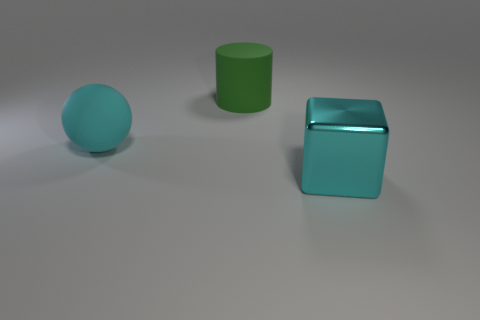The cyan object that is the same size as the cyan ball is what shape?
Your response must be concise. Cube. Is the color of the large block the same as the large matte thing that is on the right side of the rubber sphere?
Make the answer very short. No. What number of things are either things that are left of the large cyan cube or big objects in front of the large rubber cylinder?
Provide a short and direct response. 3. There is a sphere that is the same size as the green rubber cylinder; what material is it?
Your response must be concise. Rubber. How many other objects are there of the same material as the cylinder?
Ensure brevity in your answer.  1. There is a large cyan thing that is to the right of the large green rubber thing; is it the same shape as the large matte object that is on the right side of the rubber sphere?
Your answer should be very brief. No. There is a object that is behind the cyan object that is behind the big thing that is on the right side of the big cylinder; what color is it?
Provide a short and direct response. Green. What number of other objects are there of the same color as the large cube?
Keep it short and to the point. 1. Is the number of big cyan rubber spheres less than the number of big objects?
Keep it short and to the point. Yes. The thing that is in front of the large green object and behind the big cube is what color?
Your answer should be compact. Cyan. 